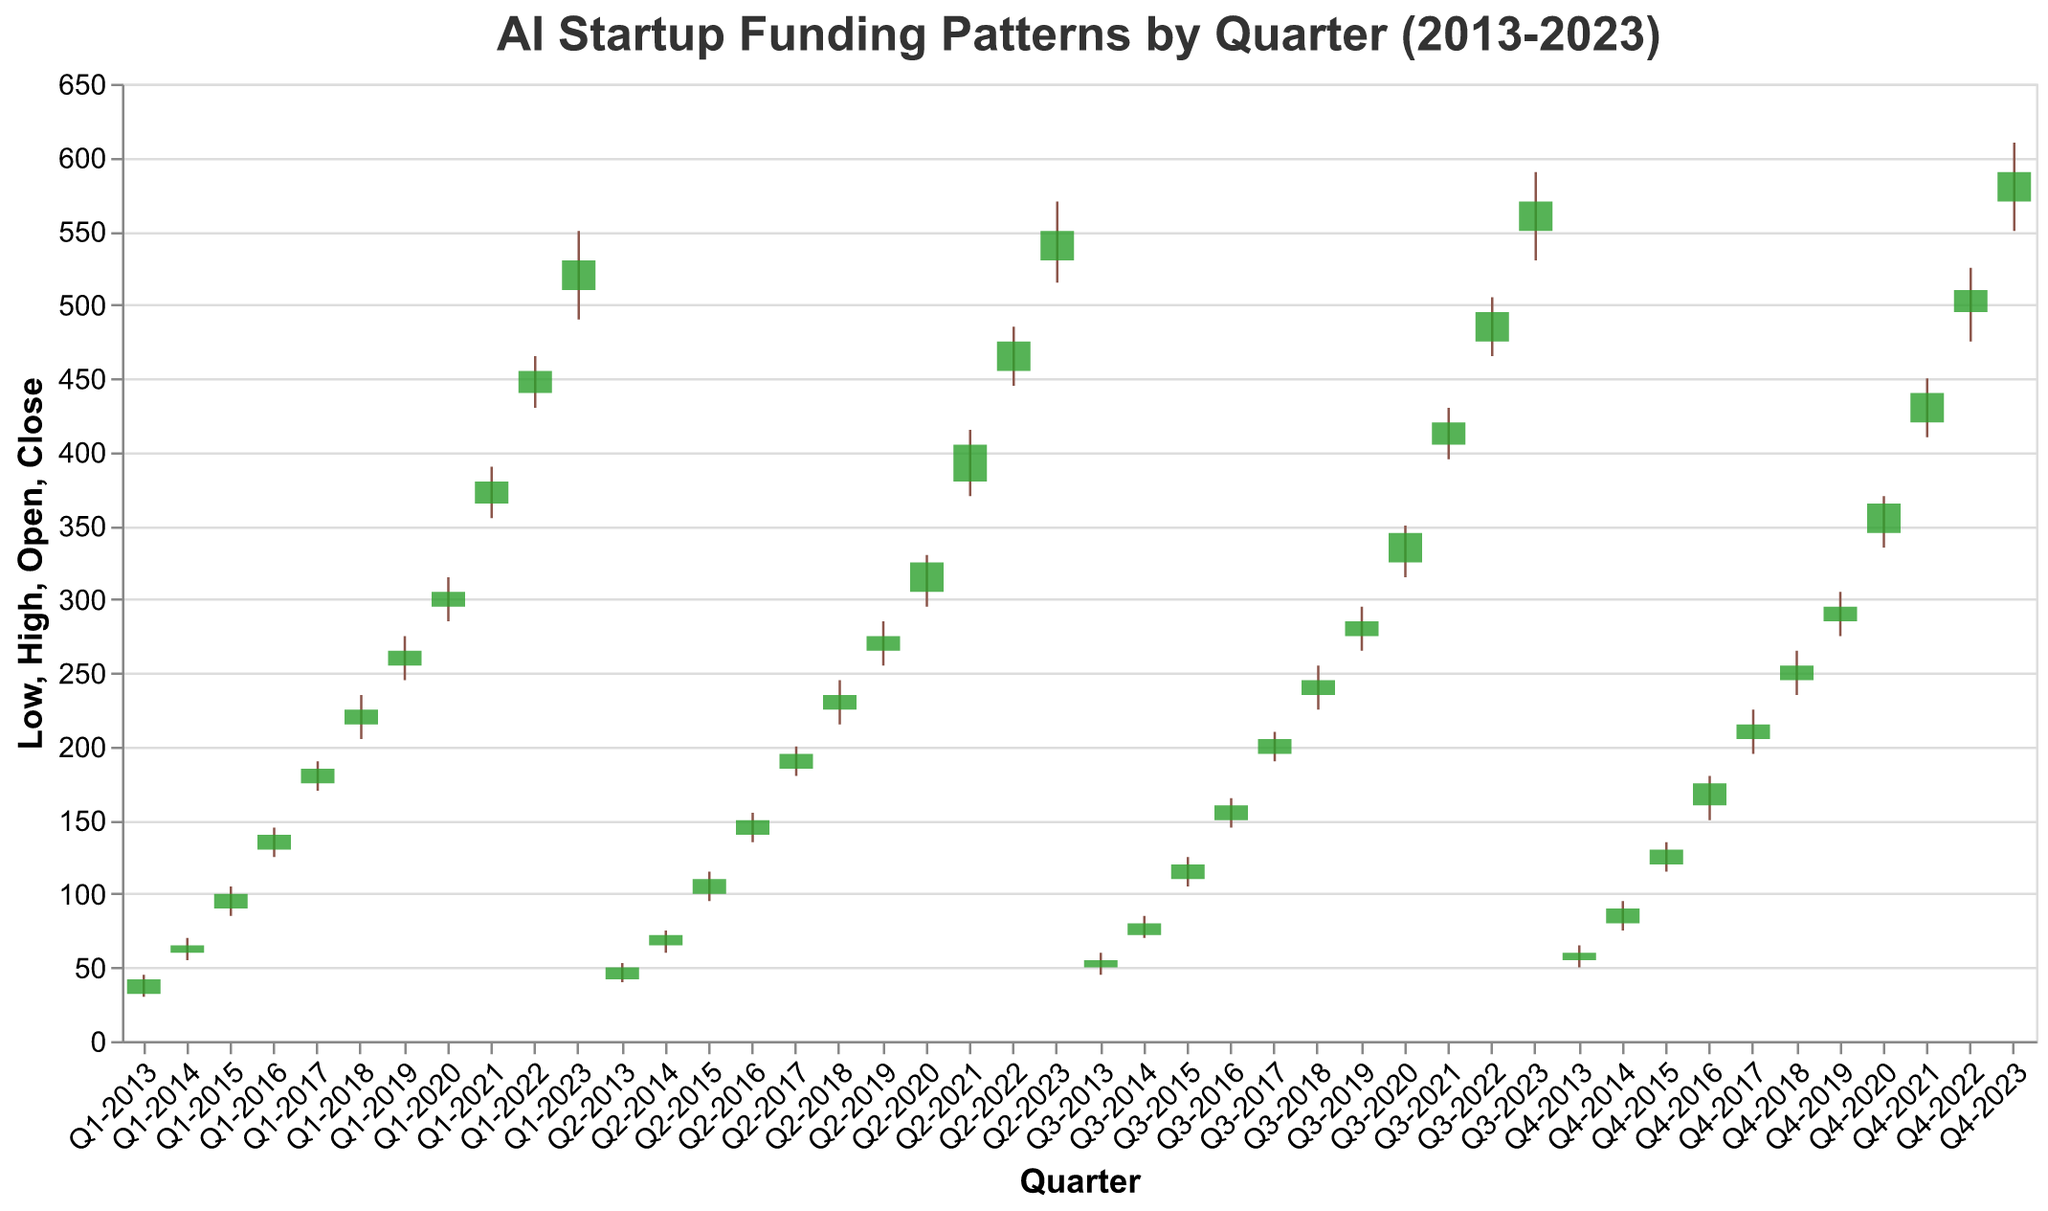what is the highest value for any quarter? The highest value for any quarter can be found by looking for the maximum value on the "High" axis of the plot. In the data, the highest value is 610 for Q4-2023.
Answer: 610 Which quarter had the lowest funding low-point in the decade? The lowest funding low-point is found by identifying the minimum value on the "Low" axis. In the data, the lowest "Low" value is 30 for Q1-2013.
Answer: Q1-2013 How many companies show a decrease in funding from open to close within a single quarter? Count the number of quarters where the "Close" value is less than the "Open" value. Going through the data, there are no quarters where the close value is less than the open value.
Answer: 0 What is the overall trend in funding from the first quarter of 2013 to the last quarter of 2023? The overall trend can be evaluated by noting the initial and final values over the time period. The data starts at 32 for Q1-2013 and ends at 590 for Q4-2023. This indicates an overall increasing trend in funding.
Answer: Increasing Which quarter had the greatest intra-quarter fluctuation? Intra-quarter fluctuation is calculated as the difference between the "High" and "Low" values for each quarter. For Q4-2020, the fluctuation is 370 - 335 = 35, which is the maximum fluctuation identified.
Answer: Q4-2020 What is the average closing value for the quarters in the year 2019? The closing values for 2019 are 265, 275, 285, and 295. Summing these gives 1120 and dividing by 4 (number of quarters) gives 280 as the average closing value for 2019.
Answer: 280 Which company received the highest amount of funding in a single quarter? The highest amount of funding is represented by the highest "High" value. For Q4-2023, it's 610 recorded by BlackThorn Therapeutics.
Answer: BlackThorn Therapeutics How many quarters had high funding values greater than 300? Count the number of quarters where the "High" value is greater than 300. Going through the data, there are 20 such quarters.
Answer: 20 